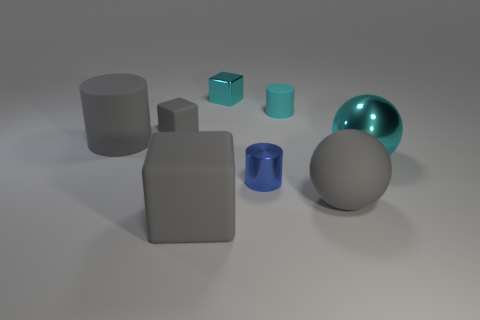What number of gray matte things are both on the right side of the big block and to the left of the large rubber block?
Offer a terse response. 0. What number of cyan objects are the same shape as the blue metal object?
Give a very brief answer. 1. What is the color of the rubber cube right of the gray cube that is behind the tiny blue shiny cylinder?
Offer a terse response. Gray. Is the shape of the large cyan thing the same as the tiny metal thing in front of the tiny matte cube?
Your answer should be compact. No. What is the tiny cyan object that is to the right of the cyan thing behind the rubber object that is behind the small gray matte object made of?
Your answer should be very brief. Rubber. Is there a gray rubber thing of the same size as the shiny cube?
Keep it short and to the point. Yes. There is a gray cylinder that is made of the same material as the tiny cyan cylinder; what size is it?
Keep it short and to the point. Large. What is the shape of the small cyan metallic object?
Your answer should be very brief. Cube. Are the gray cylinder and the small cylinder that is in front of the large gray matte cylinder made of the same material?
Make the answer very short. No. How many objects are either metal cylinders or rubber cubes?
Keep it short and to the point. 3. 